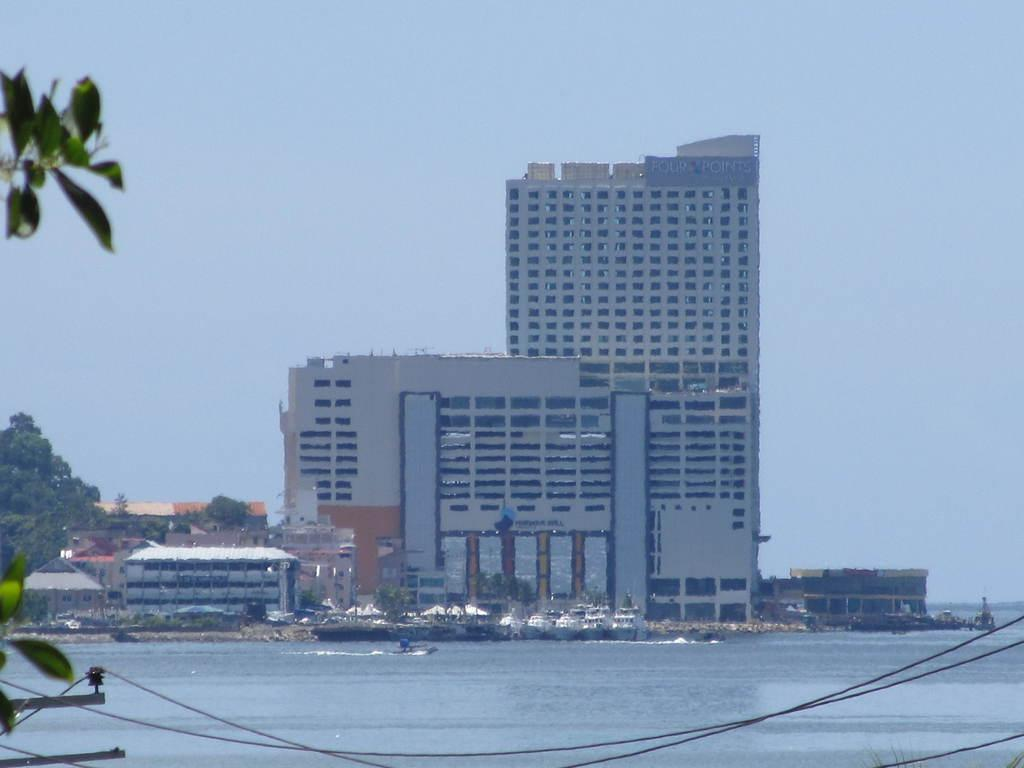What type of structures are present in the image? There are buildings in the image. What feature do the buildings have? The buildings have windows. What natural element is visible in the image? There is water visible in the image. What type of plant can be seen in the image? There is a tree in the image. What part of the natural environment is visible in the image? The sky is visible in the image. What man-made objects are present in the image? There are electric wires in the image. What is floating on the water in the image? There is a boat in the water. What discovery was made during the journey depicted in the image? There is no journey depicted in the image, so it's not possible to determine any discoveries made. 